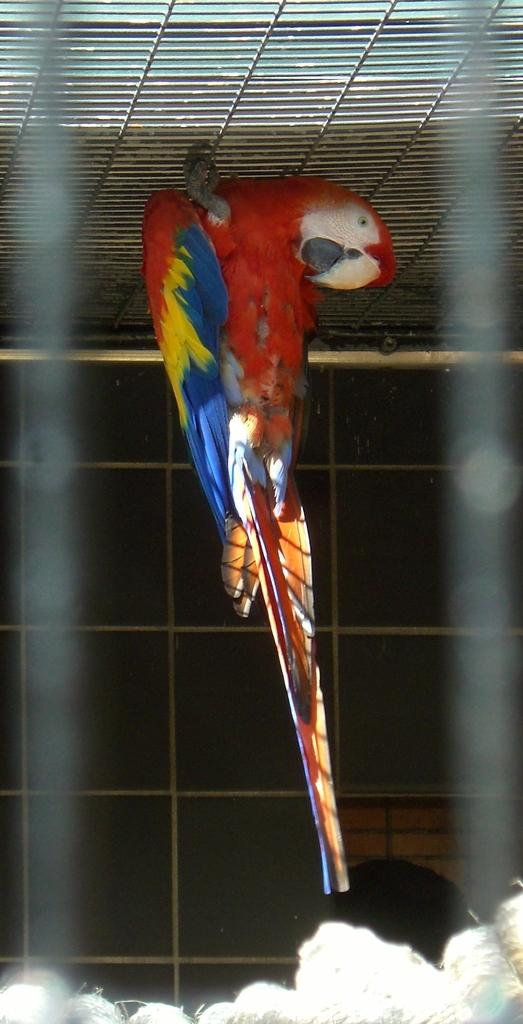What type of animal is present in the image? There is a bird in the image. Can you describe the bird's surroundings? The bird is in a cage. What type of quilt is hanging on the wall in the image? There is no quilt present in the image; it only features a bird in a cage. 